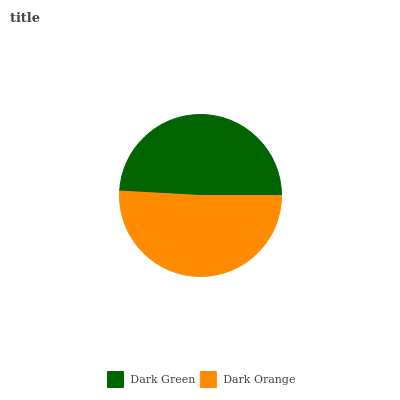Is Dark Green the minimum?
Answer yes or no. Yes. Is Dark Orange the maximum?
Answer yes or no. Yes. Is Dark Orange the minimum?
Answer yes or no. No. Is Dark Orange greater than Dark Green?
Answer yes or no. Yes. Is Dark Green less than Dark Orange?
Answer yes or no. Yes. Is Dark Green greater than Dark Orange?
Answer yes or no. No. Is Dark Orange less than Dark Green?
Answer yes or no. No. Is Dark Orange the high median?
Answer yes or no. Yes. Is Dark Green the low median?
Answer yes or no. Yes. Is Dark Green the high median?
Answer yes or no. No. Is Dark Orange the low median?
Answer yes or no. No. 